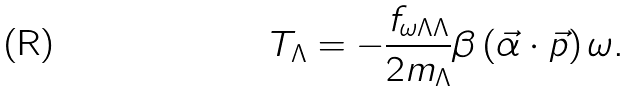Convert formula to latex. <formula><loc_0><loc_0><loc_500><loc_500>T _ { \Lambda } = - \frac { f _ { \omega \Lambda \Lambda } } { 2 m _ { \Lambda } } \beta \left ( \vec { \alpha } \cdot \vec { p } \right ) \omega .</formula> 